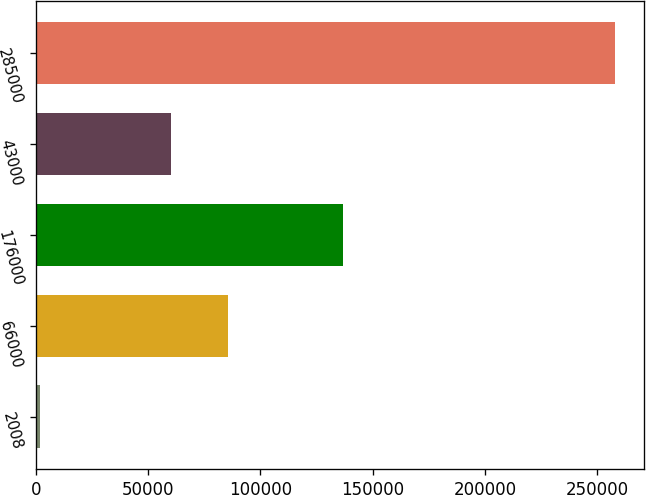<chart> <loc_0><loc_0><loc_500><loc_500><bar_chart><fcel>2008<fcel>66000<fcel>176000<fcel>43000<fcel>285000<nl><fcel>2007<fcel>85599.3<fcel>137000<fcel>60000<fcel>258000<nl></chart> 